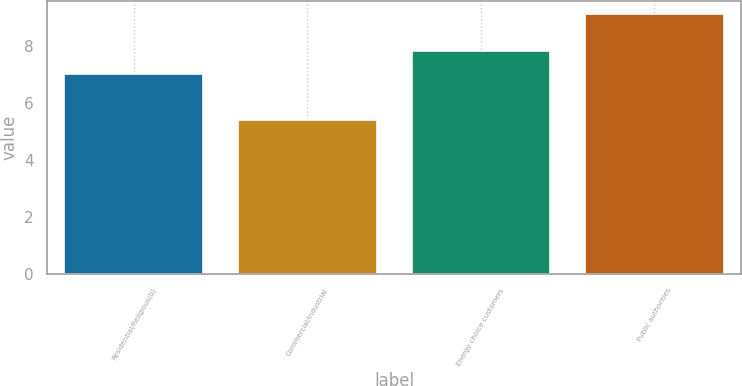Convert chart to OTSL. <chart><loc_0><loc_0><loc_500><loc_500><bar_chart><fcel>Residential/Religious(b)<fcel>Commercial/Industrial<fcel>Energy choice customers<fcel>Public authorities<nl><fcel>7<fcel>5.4<fcel>7.8<fcel>9.1<nl></chart> 